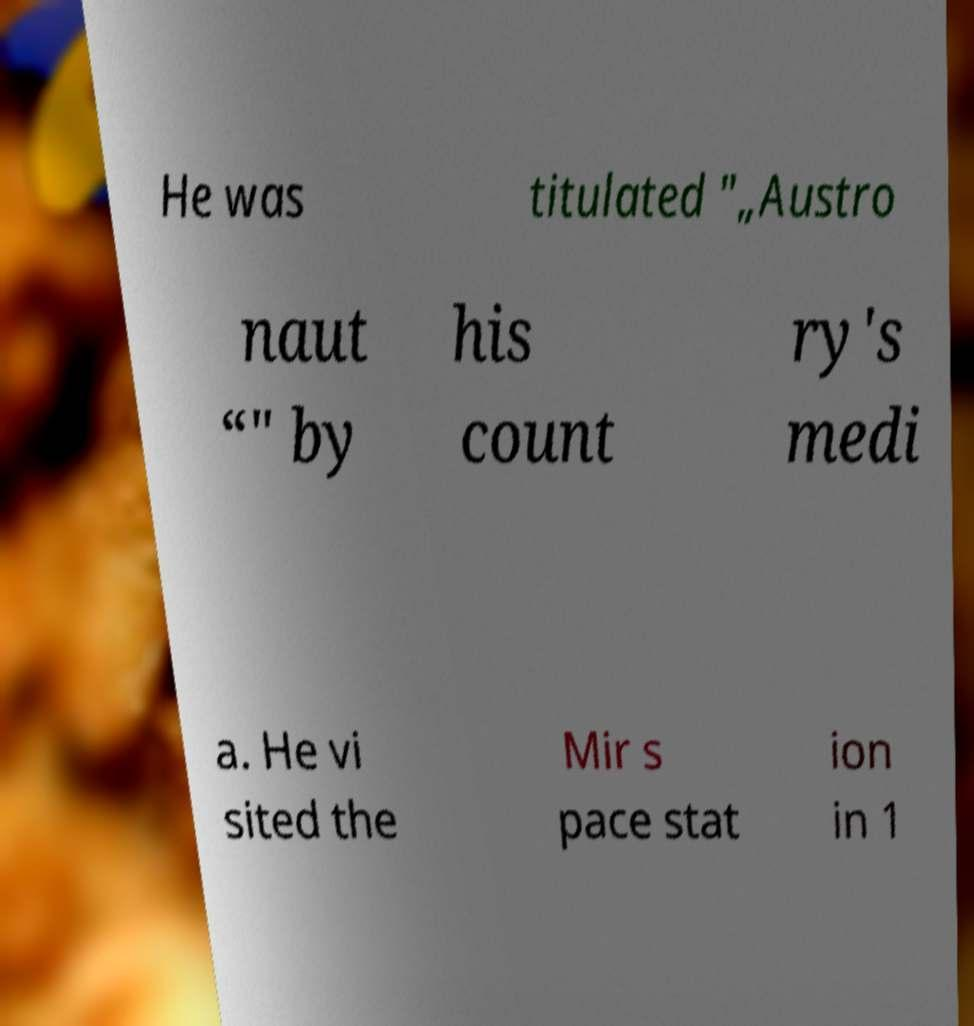Can you read and provide the text displayed in the image?This photo seems to have some interesting text. Can you extract and type it out for me? He was titulated "„Austro naut “" by his count ry's medi a. He vi sited the Mir s pace stat ion in 1 